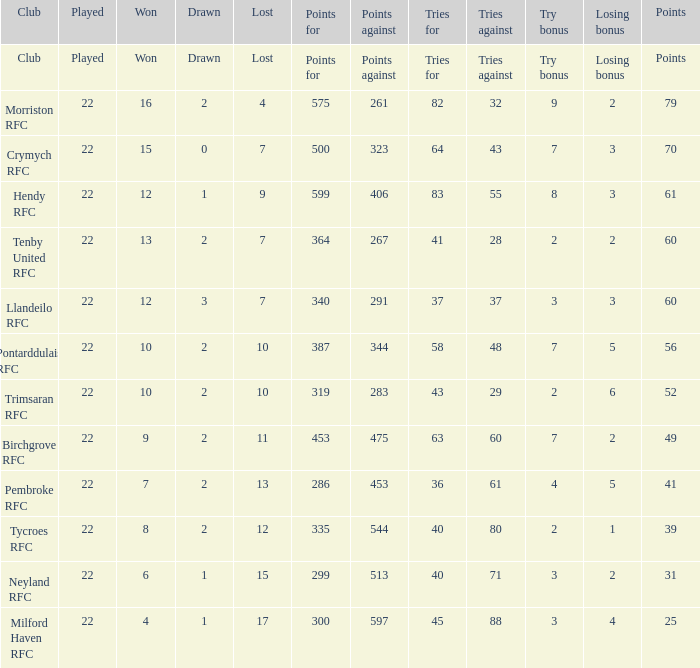What's the won with points against being 597 4.0. 